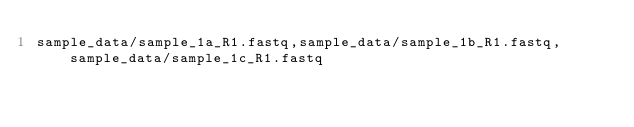<code> <loc_0><loc_0><loc_500><loc_500><_SQL_>sample_data/sample_1a_R1.fastq,sample_data/sample_1b_R1.fastq,sample_data/sample_1c_R1.fastq
</code> 